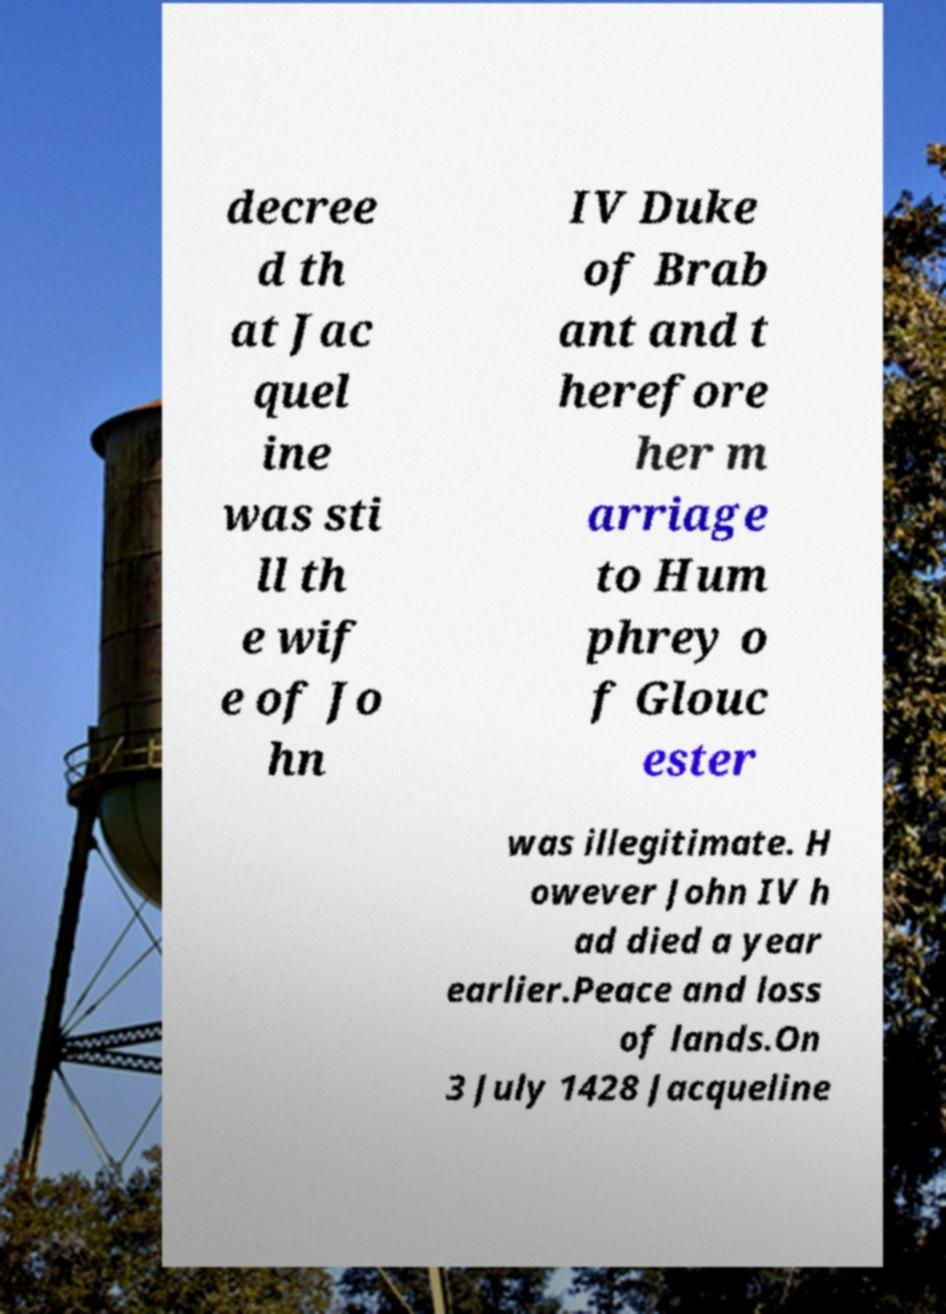Please identify and transcribe the text found in this image. decree d th at Jac quel ine was sti ll th e wif e of Jo hn IV Duke of Brab ant and t herefore her m arriage to Hum phrey o f Glouc ester was illegitimate. H owever John IV h ad died a year earlier.Peace and loss of lands.On 3 July 1428 Jacqueline 